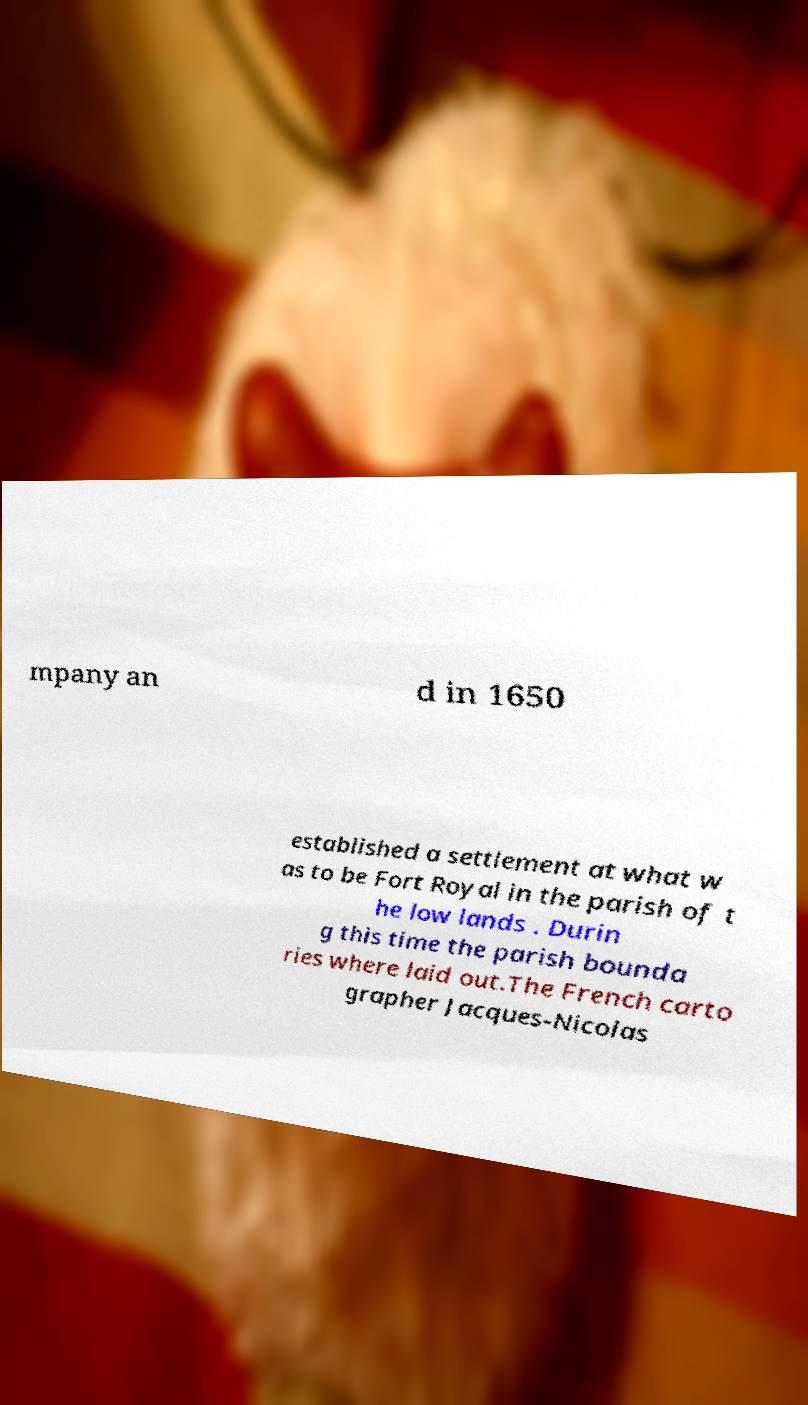Please read and relay the text visible in this image. What does it say? mpany an d in 1650 established a settlement at what w as to be Fort Royal in the parish of t he low lands . Durin g this time the parish bounda ries where laid out.The French carto grapher Jacques-Nicolas 